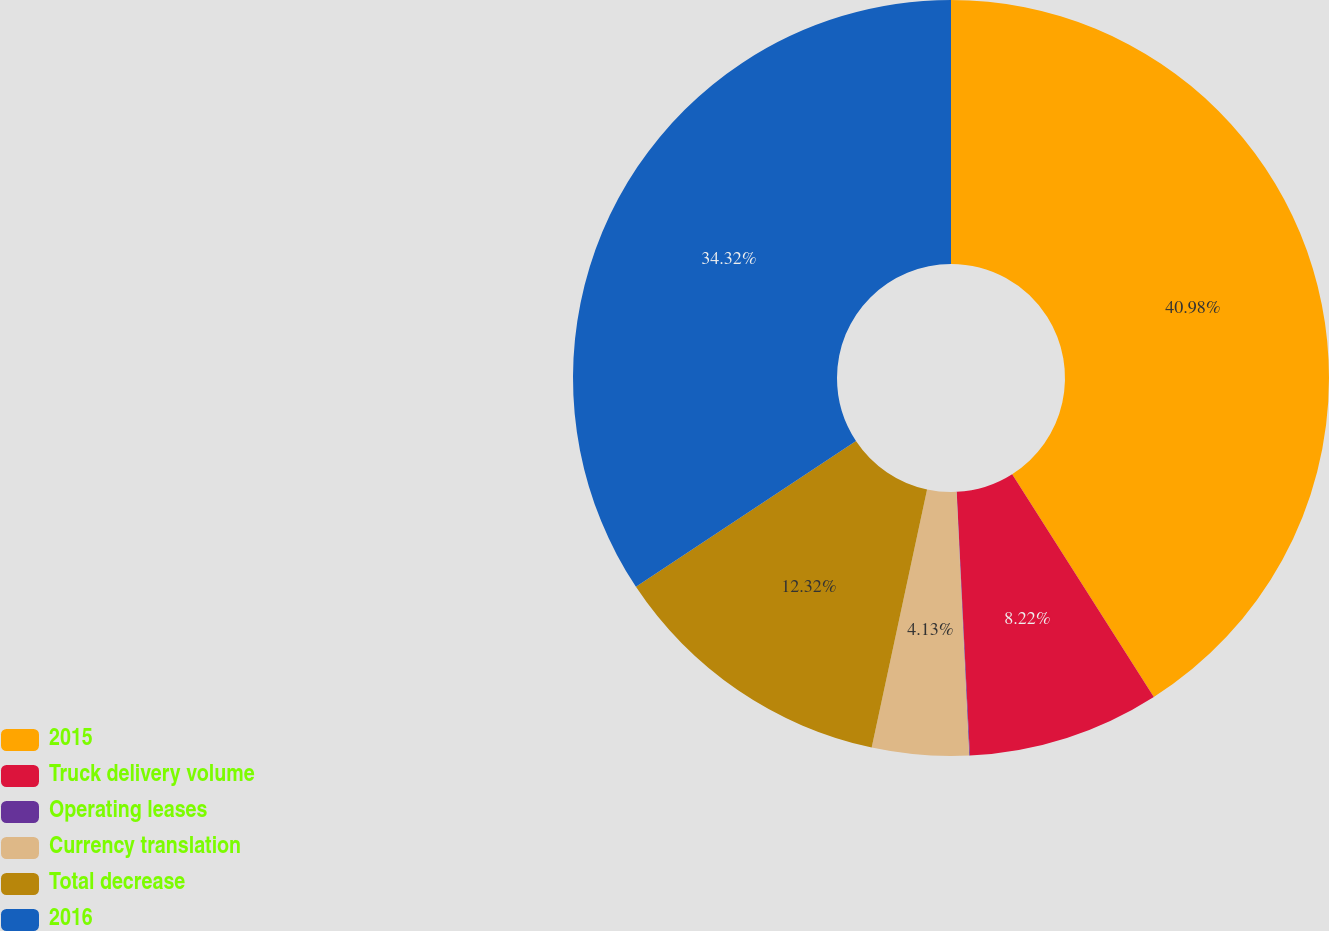Convert chart to OTSL. <chart><loc_0><loc_0><loc_500><loc_500><pie_chart><fcel>2015<fcel>Truck delivery volume<fcel>Operating leases<fcel>Currency translation<fcel>Total decrease<fcel>2016<nl><fcel>40.99%<fcel>8.22%<fcel>0.03%<fcel>4.13%<fcel>12.32%<fcel>34.32%<nl></chart> 